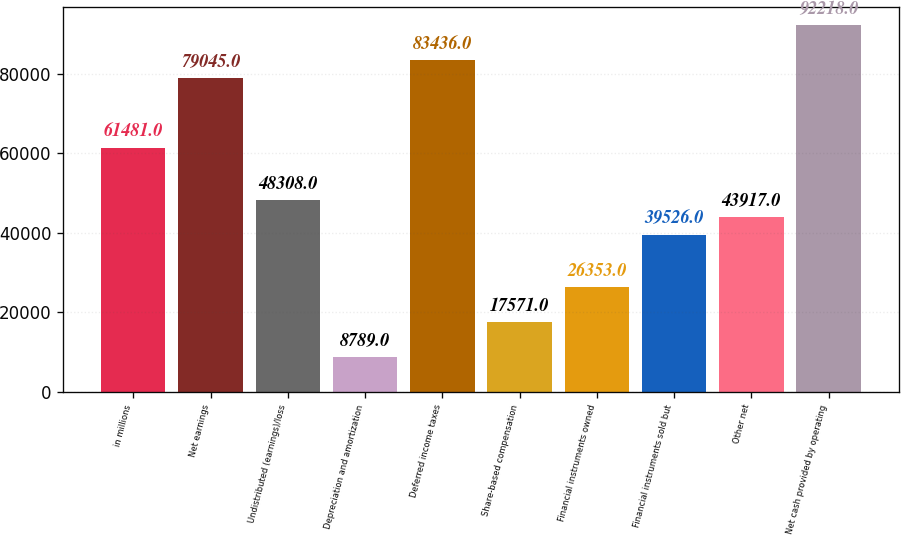Convert chart. <chart><loc_0><loc_0><loc_500><loc_500><bar_chart><fcel>in millions<fcel>Net earnings<fcel>Undistributed (earnings)/loss<fcel>Depreciation and amortization<fcel>Deferred income taxes<fcel>Share-based compensation<fcel>Financial instruments owned<fcel>Financial instruments sold but<fcel>Other net<fcel>Net cash provided by operating<nl><fcel>61481<fcel>79045<fcel>48308<fcel>8789<fcel>83436<fcel>17571<fcel>26353<fcel>39526<fcel>43917<fcel>92218<nl></chart> 